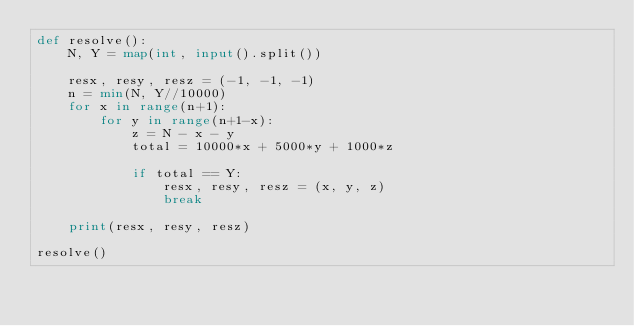Convert code to text. <code><loc_0><loc_0><loc_500><loc_500><_Python_>def resolve():
    N, Y = map(int, input().split())

    resx, resy, resz = (-1, -1, -1)
    n = min(N, Y//10000)
    for x in range(n+1):
        for y in range(n+1-x):
            z = N - x - y
            total = 10000*x + 5000*y + 1000*z

            if total == Y:
                resx, resy, resz = (x, y, z)
                break
    
    print(resx, resy, resz)
    
resolve()</code> 